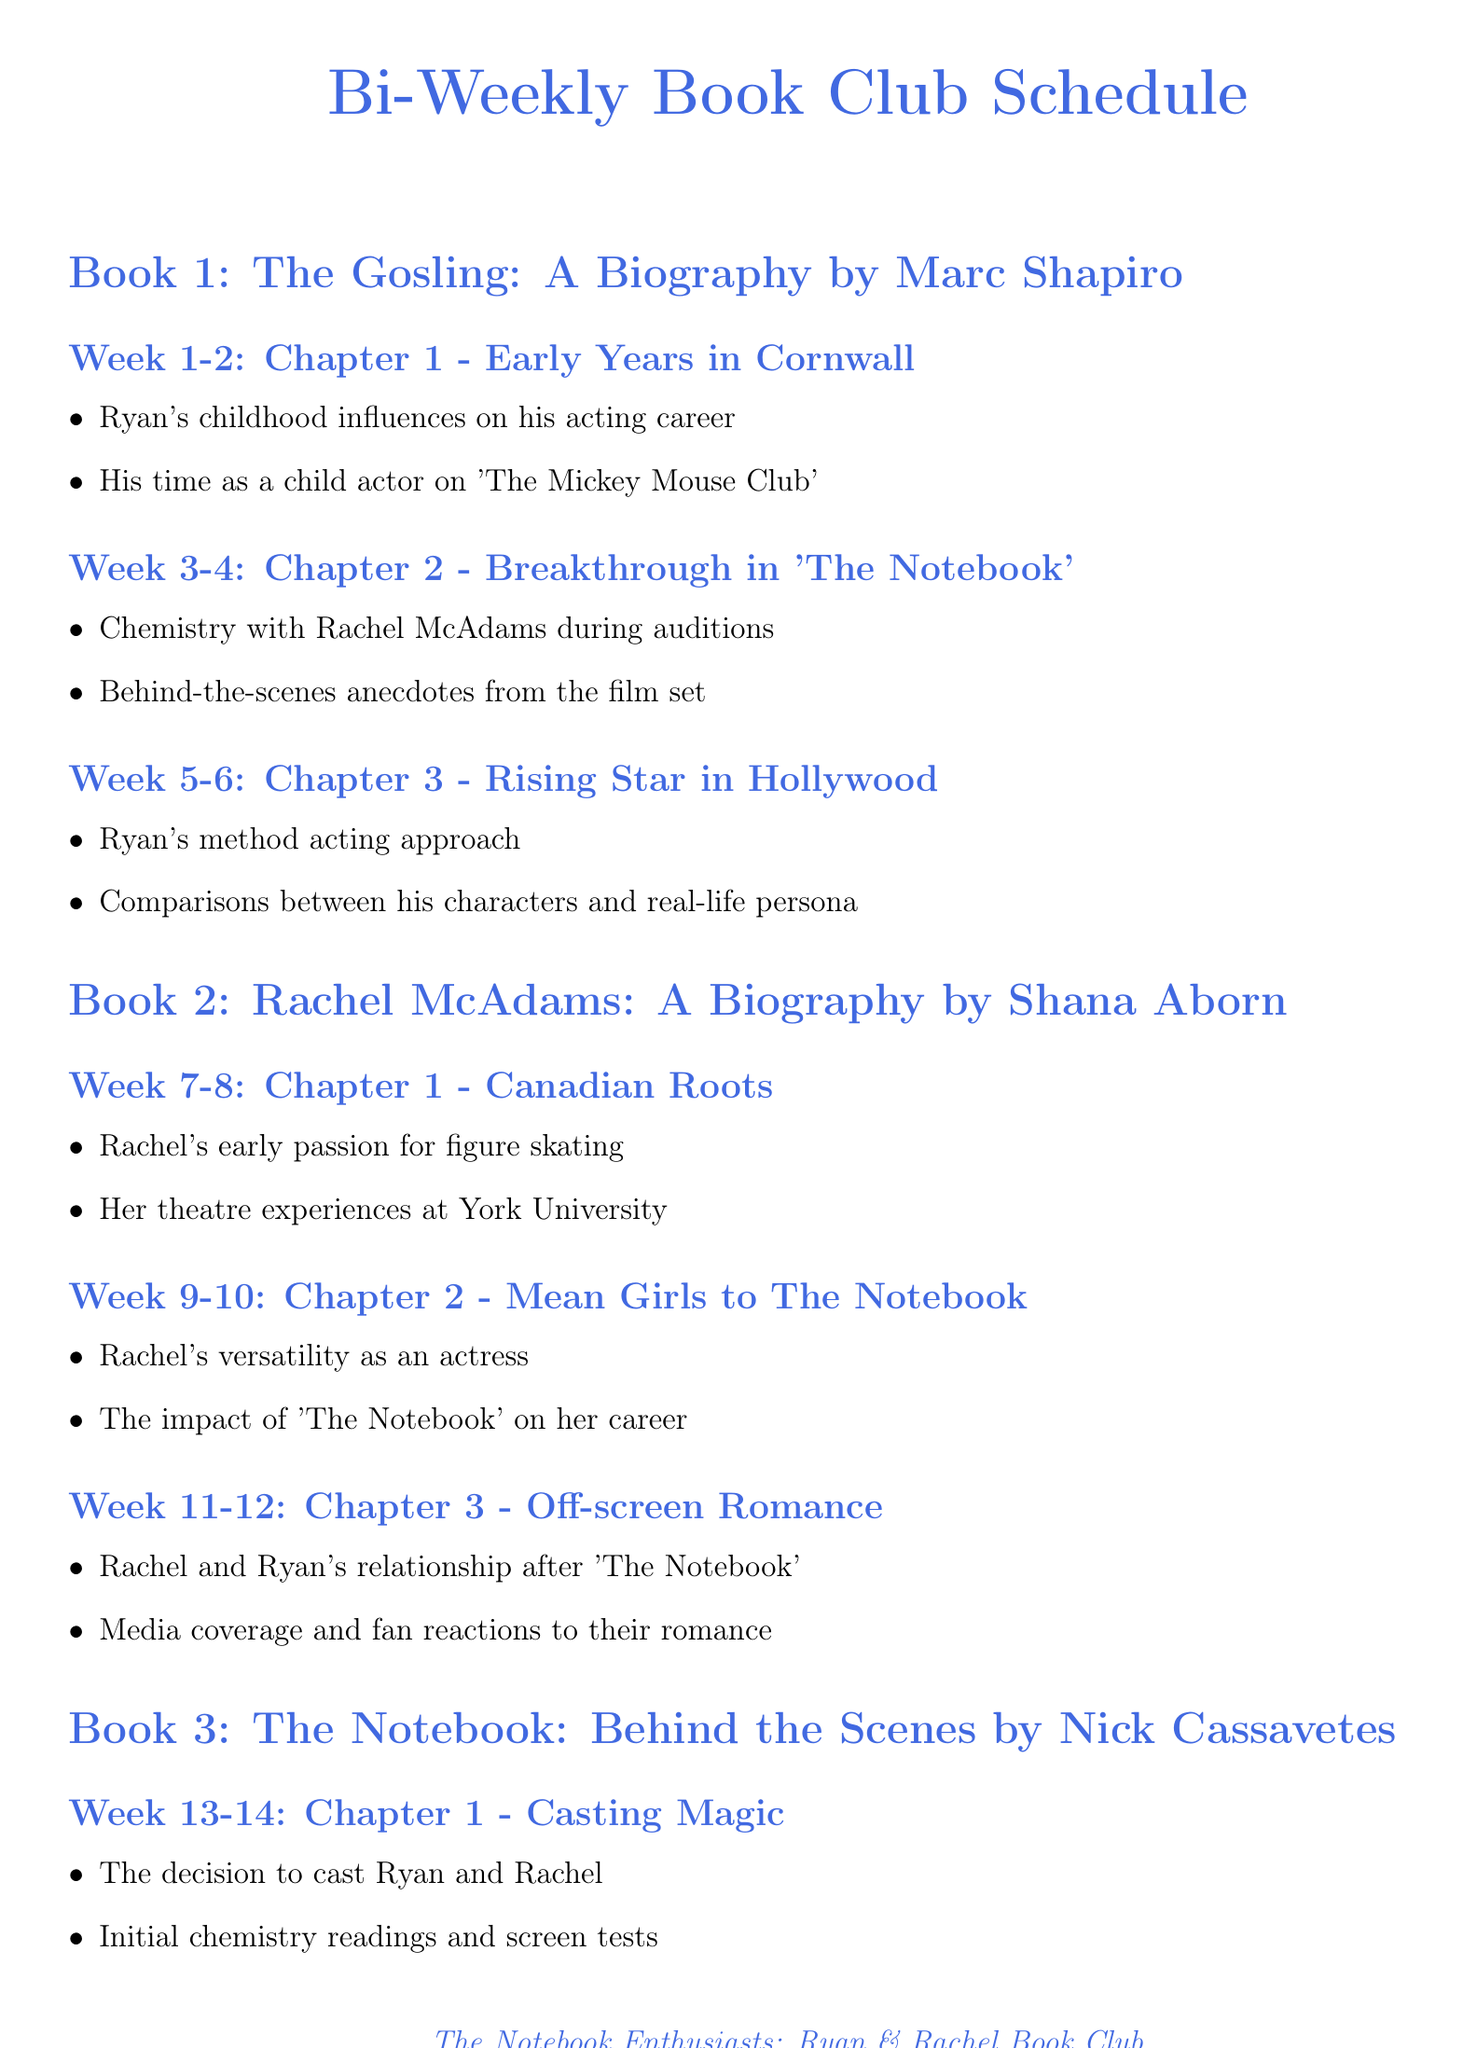What is the name of the book club? The document states the book club is called "The Notebook Enthusiasts: Ryan & Rachel Book Club."
Answer: The Notebook Enthusiasts: Ryan & Rachel Book Club How often does the book club meet? The document mentions that the meeting frequency is bi-weekly.
Answer: Bi-weekly Who is the author of "The Gosling: A Biography"? The document lists Marc Shapiro as the author of this biography.
Answer: Marc Shapiro What chapter discusses Rachel and Ryan's relationship after 'The Notebook'? The document states this topic is covered in Chapter 3 of "Rachel McAdams: A Biography."
Answer: Chapter 3 Which additional material features Ryan Gosling on The Graham Norton Show? The document identifies this material as an interview titled "Ryan Gosling on The Graham Norton Show."
Answer: Ryan Gosling on The Graham Norton Show How many chapters are there in "Ryan & Rachel: Love On and Off Screen"? The document indicates there are three chapters in this book.
Answer: Three What is the title of Chapter 2 in "The Notebook: Behind the Scenes"? The document lists the title as "Creating Noah and Allie."
Answer: Creating Noah and Allie What week will the book club discuss the magazine article about Rachel McAdams? The document specifies this discussion will happen in Week 26.
Answer: Week 26 What impact does "The Notebook" have on Rachel McAdams' career according to Chapter 2 of her biography? The document states that this chapter discusses "The impact of 'The Notebook' on her career."
Answer: The impact of 'The Notebook' on her career 